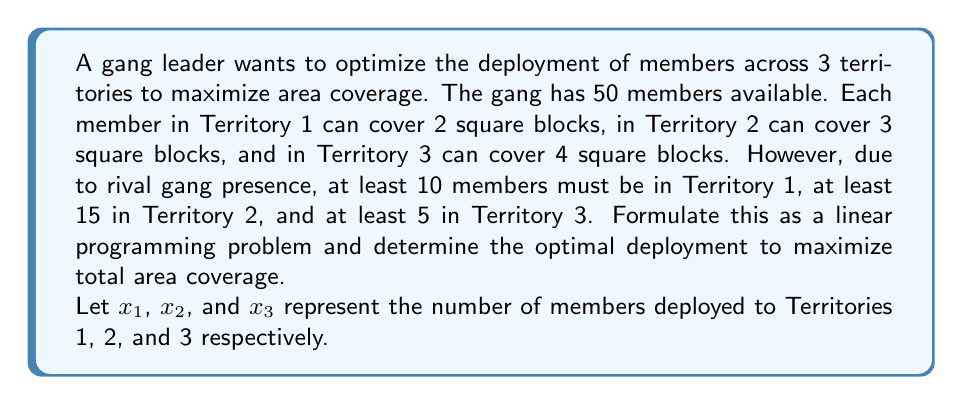Provide a solution to this math problem. To formulate this as a linear programming problem, we need to define the objective function and constraints:

1. Objective function:
   Maximize total area coverage: $Z = 2x_1 + 3x_2 + 4x_3$

2. Constraints:
   a) Total members: $x_1 + x_2 + x_3 \leq 50$
   b) Minimum members in Territory 1: $x_1 \geq 10$
   c) Minimum members in Territory 2: $x_2 \geq 15$
   d) Minimum members in Territory 3: $x_3 \geq 5$
   e) Non-negativity: $x_1, x_2, x_3 \geq 0$

The linear programming problem can be written as:

$$\begin{align*}
\text{Maximize } & Z = 2x_1 + 3x_2 + 4x_3 \\
\text{Subject to: } & x_1 + x_2 + x_3 \leq 50 \\
& x_1 \geq 10 \\
& x_2 \geq 15 \\
& x_3 \geq 5 \\
& x_1, x_2, x_3 \geq 0
\end{align*}$$

To solve this, we can use the simplex method or a linear programming solver. However, we can also reason through the solution:

1. We need to allocate at least 10 + 15 + 5 = 30 members to meet the minimum requirements.
2. We have 20 members left to allocate.
3. Territory 3 gives the highest coverage per member (4 square blocks), so we should allocate the remaining members there.

Therefore, the optimal solution is:
$x_1 = 10$, $x_2 = 15$, $x_3 = 25$

We can verify that this satisfies all constraints:
10 + 15 + 25 = 50 ≤ 50
$x_1 = 10 \geq 10$
$x_2 = 15 \geq 15$
$x_3 = 25 \geq 5$

The maximum area coverage is:
$Z = 2(10) + 3(15) + 4(25) = 20 + 45 + 100 = 165$ square blocks
Answer: The optimal deployment is 10 members in Territory 1, 15 members in Territory 2, and 25 members in Territory 3, resulting in a maximum area coverage of 165 square blocks. 